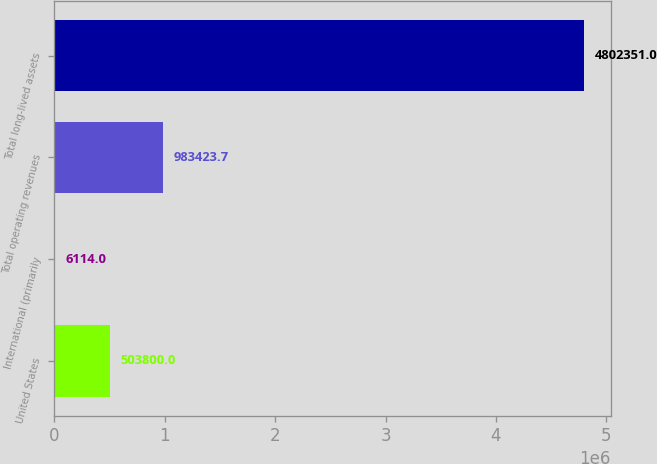Convert chart. <chart><loc_0><loc_0><loc_500><loc_500><bar_chart><fcel>United States<fcel>International (primarily<fcel>Total operating revenues<fcel>Total long-lived assets<nl><fcel>503800<fcel>6114<fcel>983424<fcel>4.80235e+06<nl></chart> 